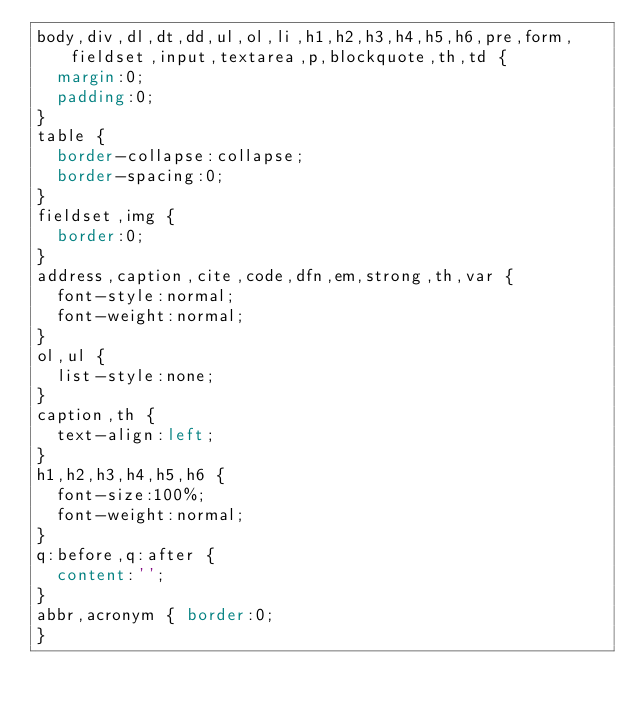Convert code to text. <code><loc_0><loc_0><loc_500><loc_500><_CSS_>body,div,dl,dt,dd,ul,ol,li,h1,h2,h3,h4,h5,h6,pre,form,fieldset,input,textarea,p,blockquote,th,td { 
	margin:0;
	padding:0;
}
table {
	border-collapse:collapse;
	border-spacing:0;
}
fieldset,img { 
	border:0;
}
address,caption,cite,code,dfn,em,strong,th,var {
	font-style:normal;
	font-weight:normal;
}
ol,ul {
	list-style:none;
}
caption,th {
	text-align:left;
}
h1,h2,h3,h4,h5,h6 {
	font-size:100%;
	font-weight:normal;
}
q:before,q:after {
	content:'';
}
abbr,acronym { border:0;
}</code> 